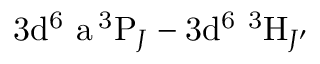<formula> <loc_0><loc_0><loc_500><loc_500>3 d ^ { 6 } \ a \, ^ { 3 } P _ { J } - 3 d ^ { 6 } \ ^ { 3 } H _ { J ^ { \prime } }</formula> 